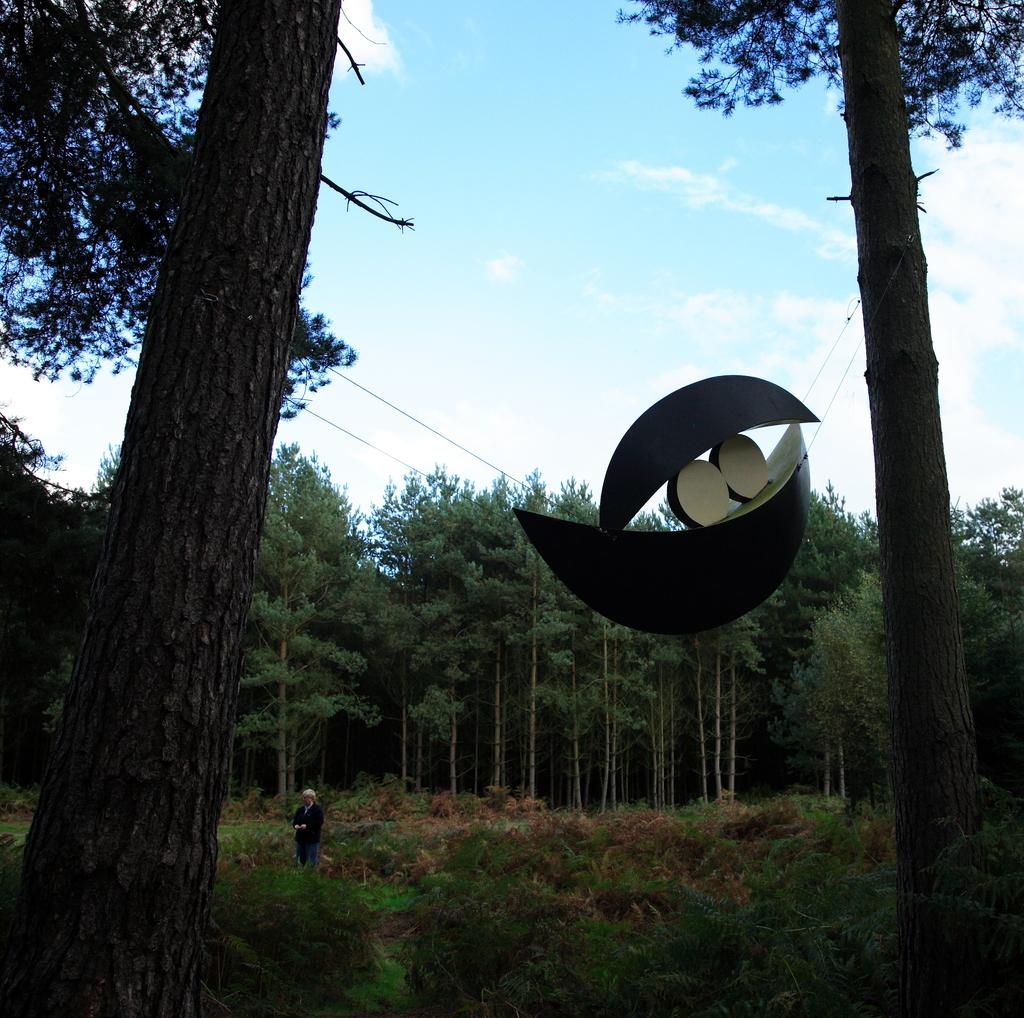What is the main setting of the image? There is a land in the image. Who or what can be seen on the land? There is a man standing on the land. What type of vegetation is present in the image? There are plants and trees in the image. Can you describe the object between the trees? There is an object between the trees, but its specific nature is not mentioned in the facts. What is visible in the background of the image? The sky is visible in the background of the image. How many sheep can be seen grazing on the land in the image? There are no sheep present in the image. What type of lip can be seen on the man's face in the image? There is no mention of a lip or any facial features in the image. 